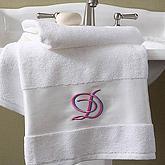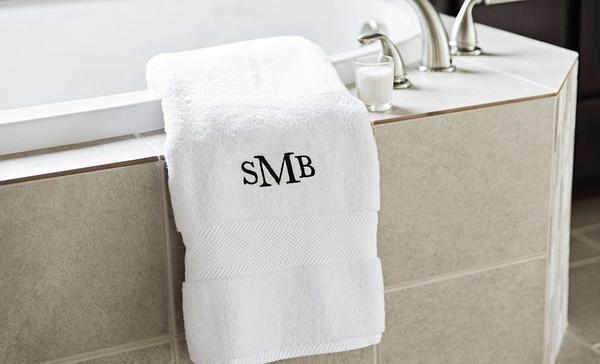The first image is the image on the left, the second image is the image on the right. Analyze the images presented: Is the assertion "Each image shows lettered towels draped near a faucet." valid? Answer yes or no. Yes. 